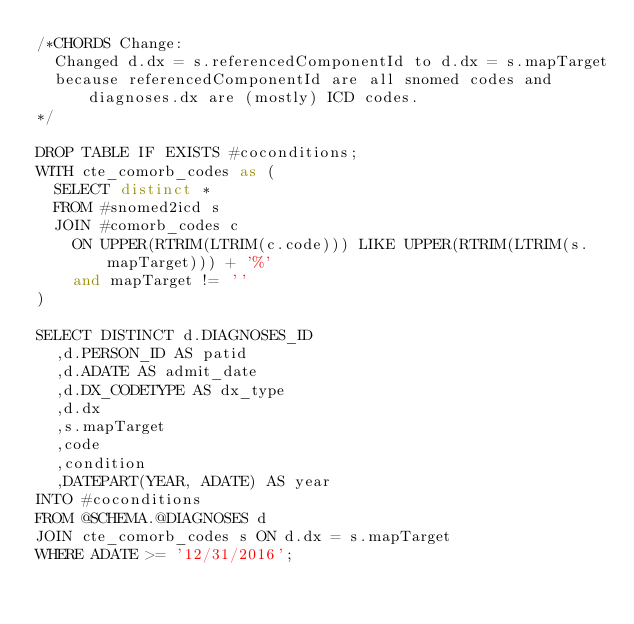<code> <loc_0><loc_0><loc_500><loc_500><_SQL_>/*CHORDS Change: 
	Changed d.dx = s.referencedComponentId to d.dx = s.mapTarget
	because referencedComponentId are all snomed codes and diagnoses.dx are (mostly) ICD codes.
*/

DROP TABLE IF EXISTS #coconditions;
WITH cte_comorb_codes as (
	SELECT distinct *
	FROM #snomed2icd s
	JOIN #comorb_codes c 
		ON UPPER(RTRIM(LTRIM(c.code))) LIKE UPPER(RTRIM(LTRIM(s.mapTarget))) + '%'
		and mapTarget != ''
)

SELECT DISTINCT d.DIAGNOSES_ID
	,d.PERSON_ID AS patid
	,d.ADATE AS admit_date
	,d.DX_CODETYPE AS dx_type
	,d.dx
	,s.mapTarget
	,code
	,condition
	,DATEPART(YEAR, ADATE) AS year
INTO #coconditions
FROM @SCHEMA.@DIAGNOSES d
JOIN cte_comorb_codes s ON d.dx = s.mapTarget
WHERE ADATE >= '12/31/2016';
</code> 